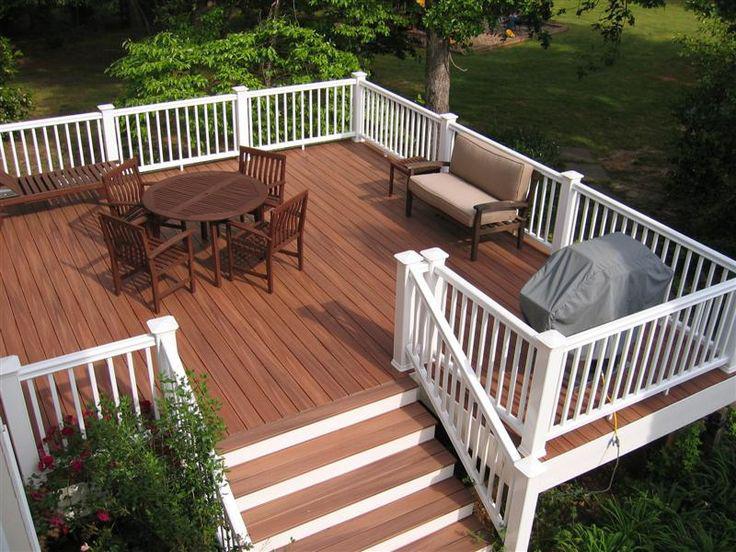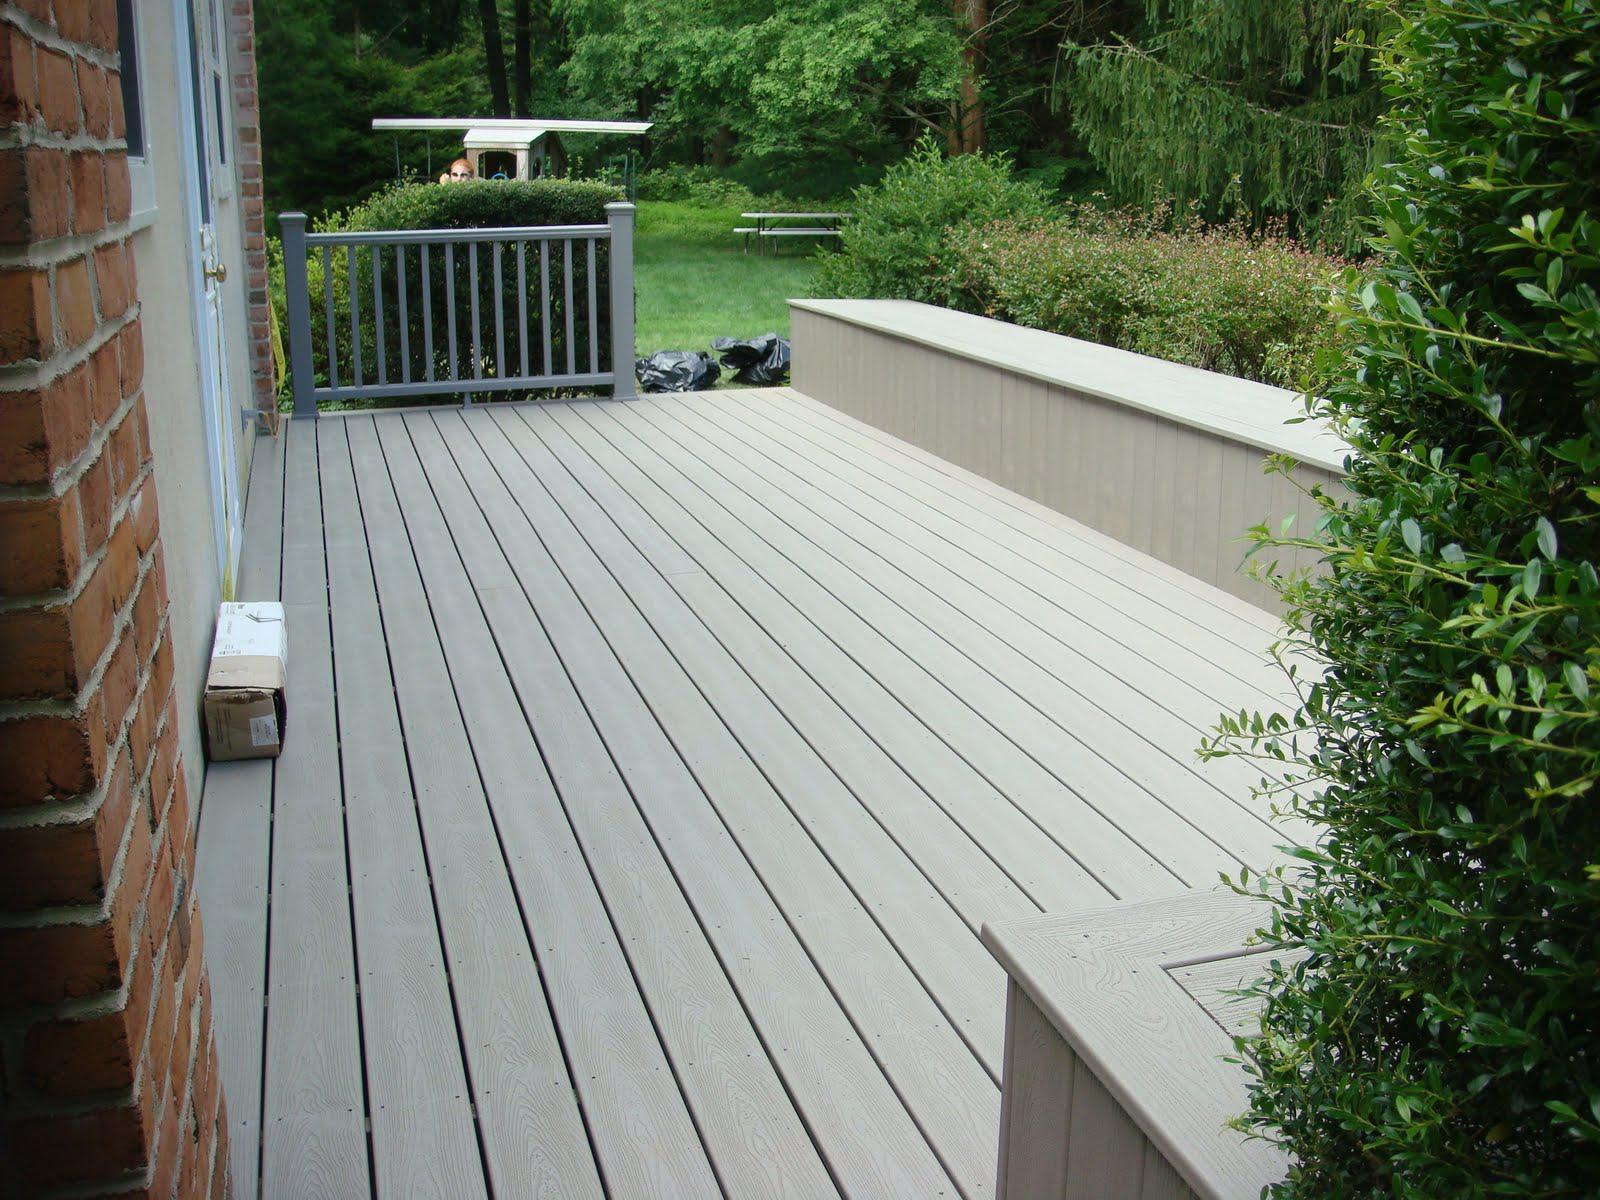The first image is the image on the left, the second image is the image on the right. Given the left and right images, does the statement "A table and 4 chairs sits on a wooden deck with a white banister." hold true? Answer yes or no. Yes. The first image is the image on the left, the second image is the image on the right. Assess this claim about the two images: "One deck has dark grey flooring with no furniture on it, and the other deck has brown stained flooring, white rails, and furniture including a table with four chairs.". Correct or not? Answer yes or no. Yes. 